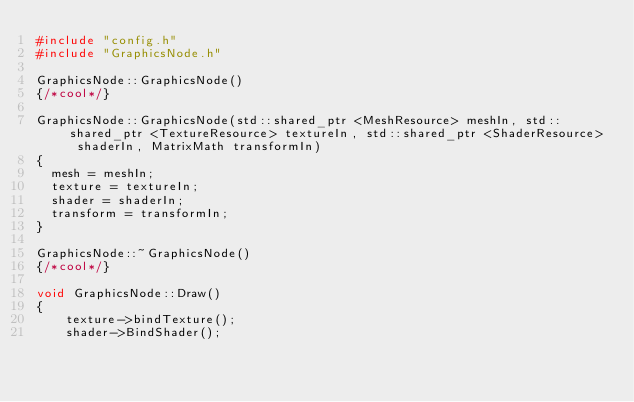Convert code to text. <code><loc_0><loc_0><loc_500><loc_500><_C++_>#include "config.h"
#include "GraphicsNode.h"

GraphicsNode::GraphicsNode()
{/*cool*/}

GraphicsNode::GraphicsNode(std::shared_ptr <MeshResource> meshIn, std::shared_ptr <TextureResource> textureIn, std::shared_ptr <ShaderResource> shaderIn, MatrixMath transformIn)
{
	mesh = meshIn;
	texture = textureIn;
	shader = shaderIn;
	transform = transformIn;
}

GraphicsNode::~GraphicsNode()
{/*cool*/}

void GraphicsNode::Draw()
{
    texture->bindTexture();
    shader->BindShader();</code> 